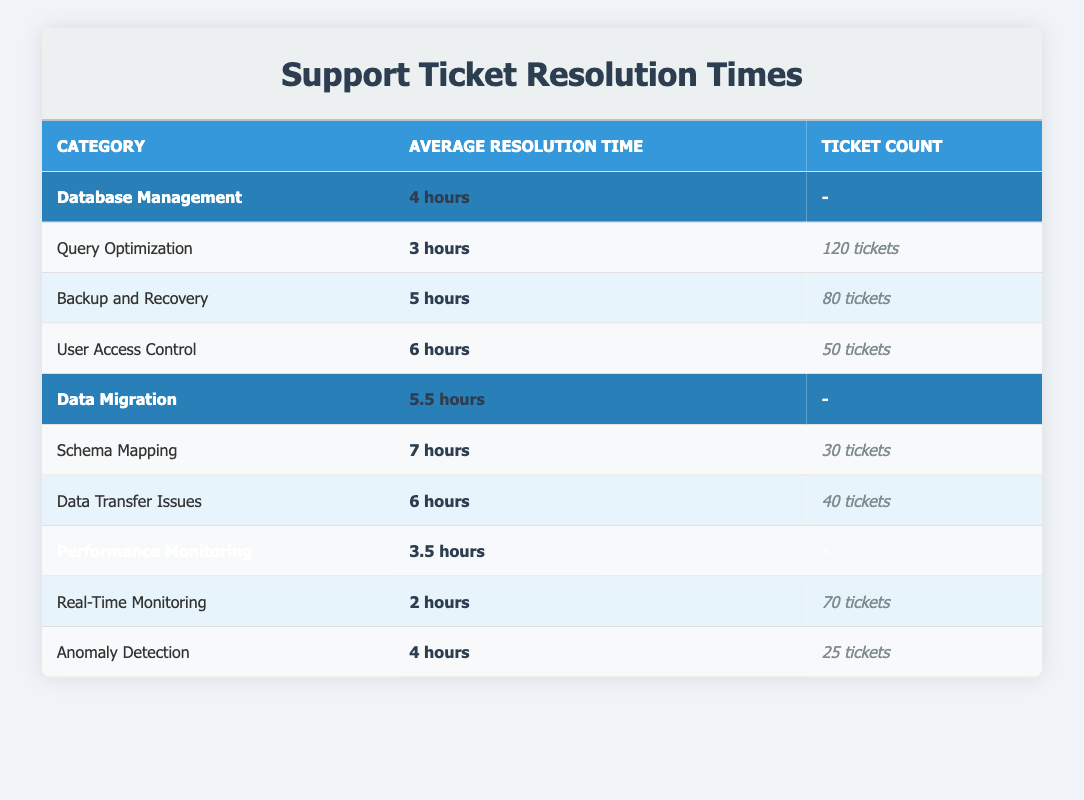What is the average resolution time for Database Management? The average resolution time for Database Management is stated in the table under the corresponding category. It specifically says "4 hours".
Answer: 4 hours Which feature under Performance Monitoring has the shortest average resolution time? In the Performance Monitoring section, the table lists two features: Real-Time Monitoring with an average resolution time of "2 hours" and Anomaly Detection with "4 hours". Among these, Real-Time Monitoring has the shorter time.
Answer: Real-Time Monitoring How many total tickets were filed for Database Management features? To calculate the total tickets for Database Management, add up the ticket counts for each feature: 120 (Query Optimization) + 80 (Backup and Recovery) + 50 (User Access Control) = 250 tickets in total.
Answer: 250 tickets Is the average resolution time for Schema Mapping longer than that of Data Transfer Issues? The average resolution time for Schema Mapping is "7 hours" while for Data Transfer Issues it is "6 hours". Since 7 hours is greater than 6 hours, the statement is true.
Answer: Yes Which category has the highest average resolution time, and what is that time? Comparing the average resolution times in the main categories: Database Management (4 hours), Data Migration (5.5 hours), and Performance Monitoring (3.5 hours), Data Migration has the highest time of "5.5 hours."
Answer: Data Migration - 5.5 hours What is the average resolution time for all the features under Data Migration? To find the average for Data Migration, first, add the resolution times for its features: 7 hours (Schema Mapping) + 6 hours (Data Transfer Issues) = 13 hours. Then divide by the number of features, which is 2, giving an average of 13/2 = 6.5 hours.
Answer: 6.5 hours Do more tickets exist for Backup and Recovery than for Schema Mapping? The table shows that Backup and Recovery has 80 tickets, while Schema Mapping has 30 tickets. 80 is greater than 30, therefore the statement is true.
Answer: Yes What is the combined average resolution time for the features under Database Management? To find the combined average resolution time, sum the average resolution times of each feature: 3 (Query Optimization) + 5 (Backup and Recovery) + 6 (User Access Control) = 14 hours. Divide by the number of features, which is 3, giving an overall average of 14/3 = approximately 4.67 hours.
Answer: Approximately 4.67 hours 